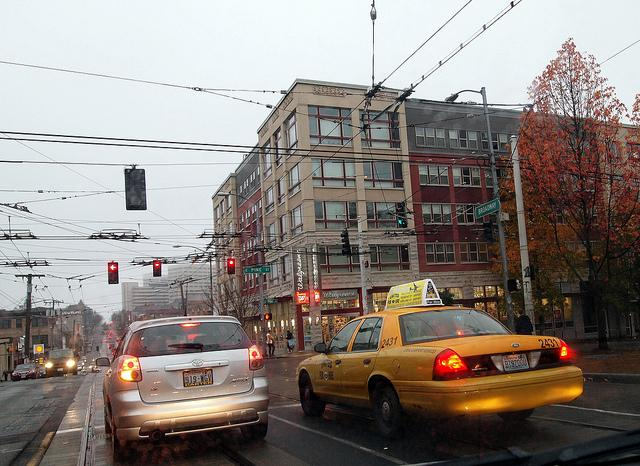Which car is stopped before white line? taxi 